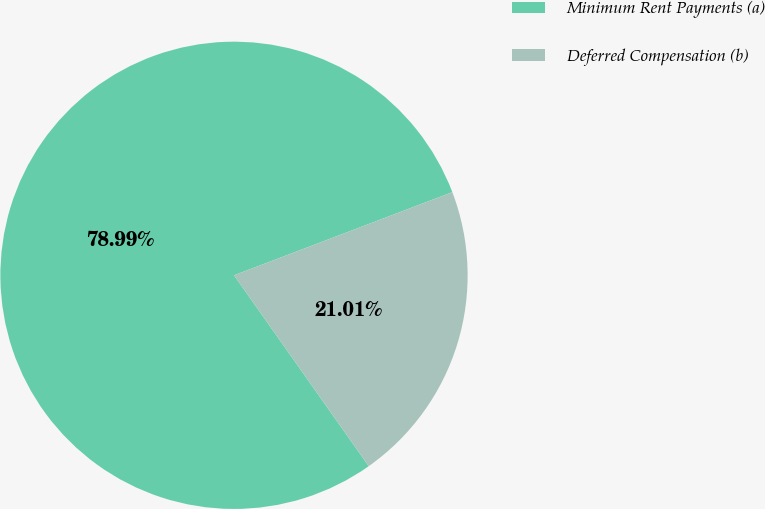Convert chart to OTSL. <chart><loc_0><loc_0><loc_500><loc_500><pie_chart><fcel>Minimum Rent Payments (a)<fcel>Deferred Compensation (b)<nl><fcel>78.99%<fcel>21.01%<nl></chart> 